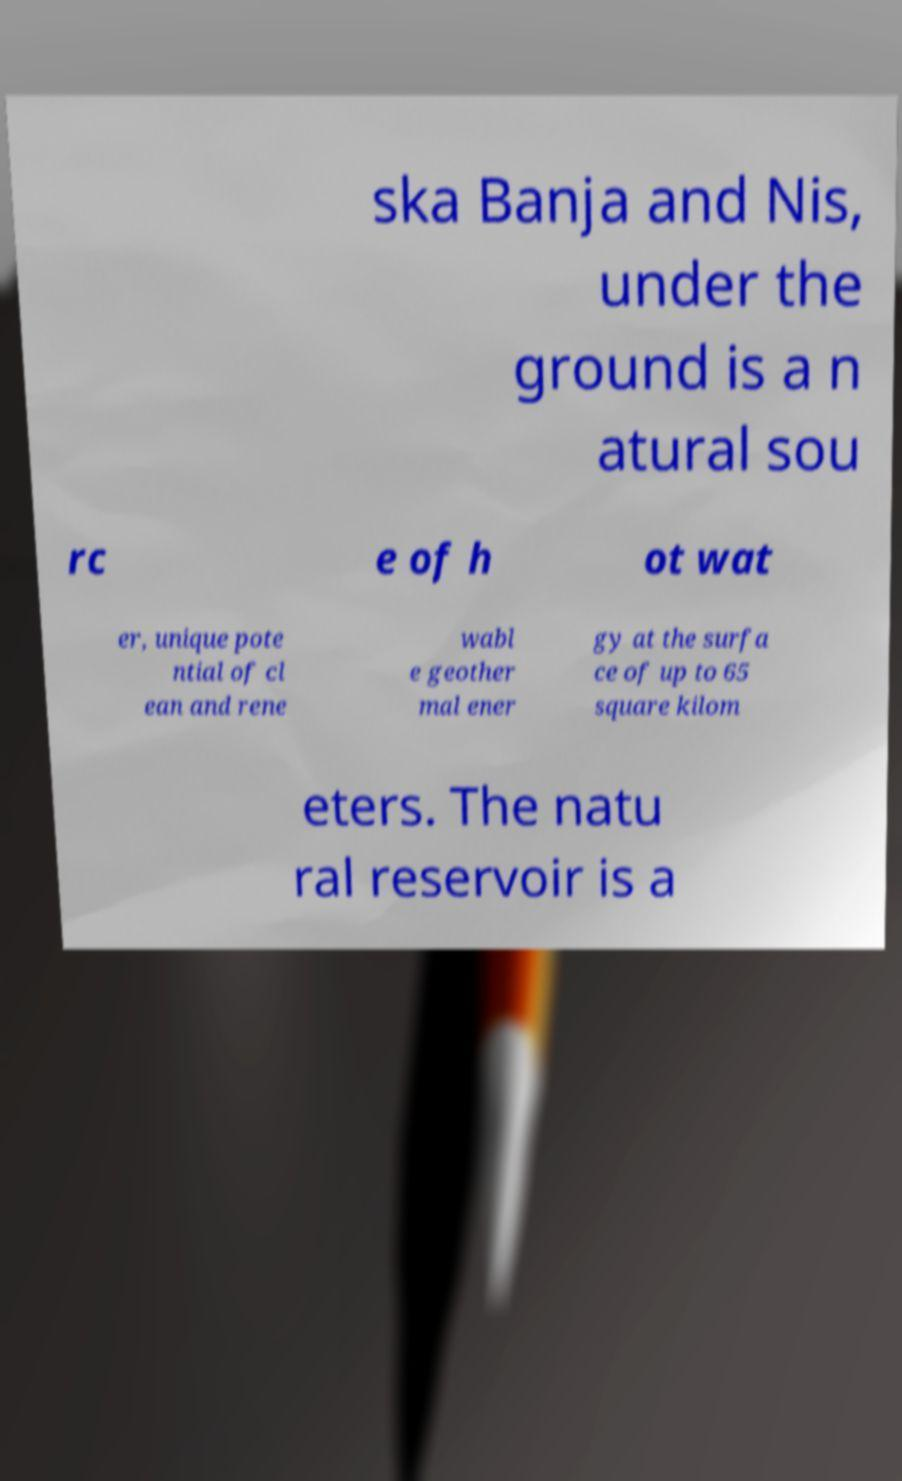Please read and relay the text visible in this image. What does it say? ska Banja and Nis, under the ground is a n atural sou rc e of h ot wat er, unique pote ntial of cl ean and rene wabl e geother mal ener gy at the surfa ce of up to 65 square kilom eters. The natu ral reservoir is a 